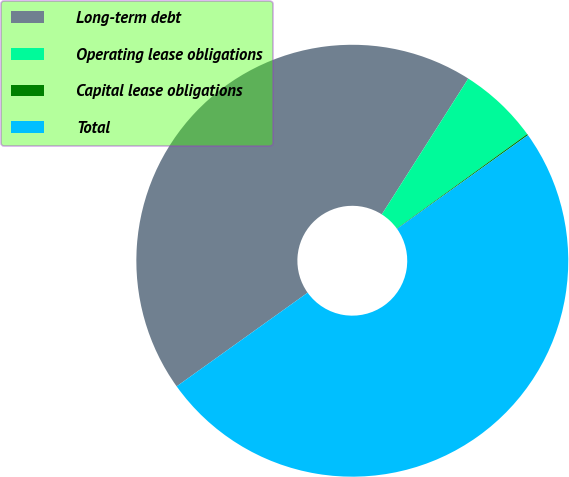<chart> <loc_0><loc_0><loc_500><loc_500><pie_chart><fcel>Long-term debt<fcel>Operating lease obligations<fcel>Capital lease obligations<fcel>Total<nl><fcel>43.91%<fcel>6.0%<fcel>0.1%<fcel>50.0%<nl></chart> 